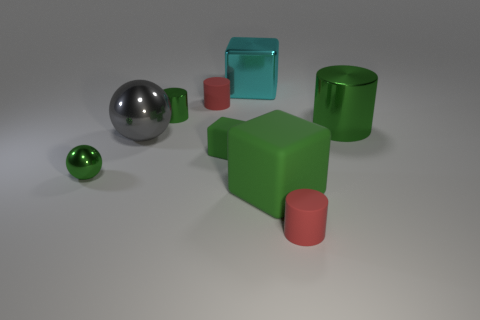Subtract 1 cylinders. How many cylinders are left? 3 Subtract all cyan cylinders. Subtract all gray cubes. How many cylinders are left? 4 Subtract all blocks. How many objects are left? 6 Subtract all large green metal cylinders. Subtract all cyan metallic cubes. How many objects are left? 7 Add 3 green shiny balls. How many green shiny balls are left? 4 Add 2 tiny cylinders. How many tiny cylinders exist? 5 Subtract 0 cyan cylinders. How many objects are left? 9 